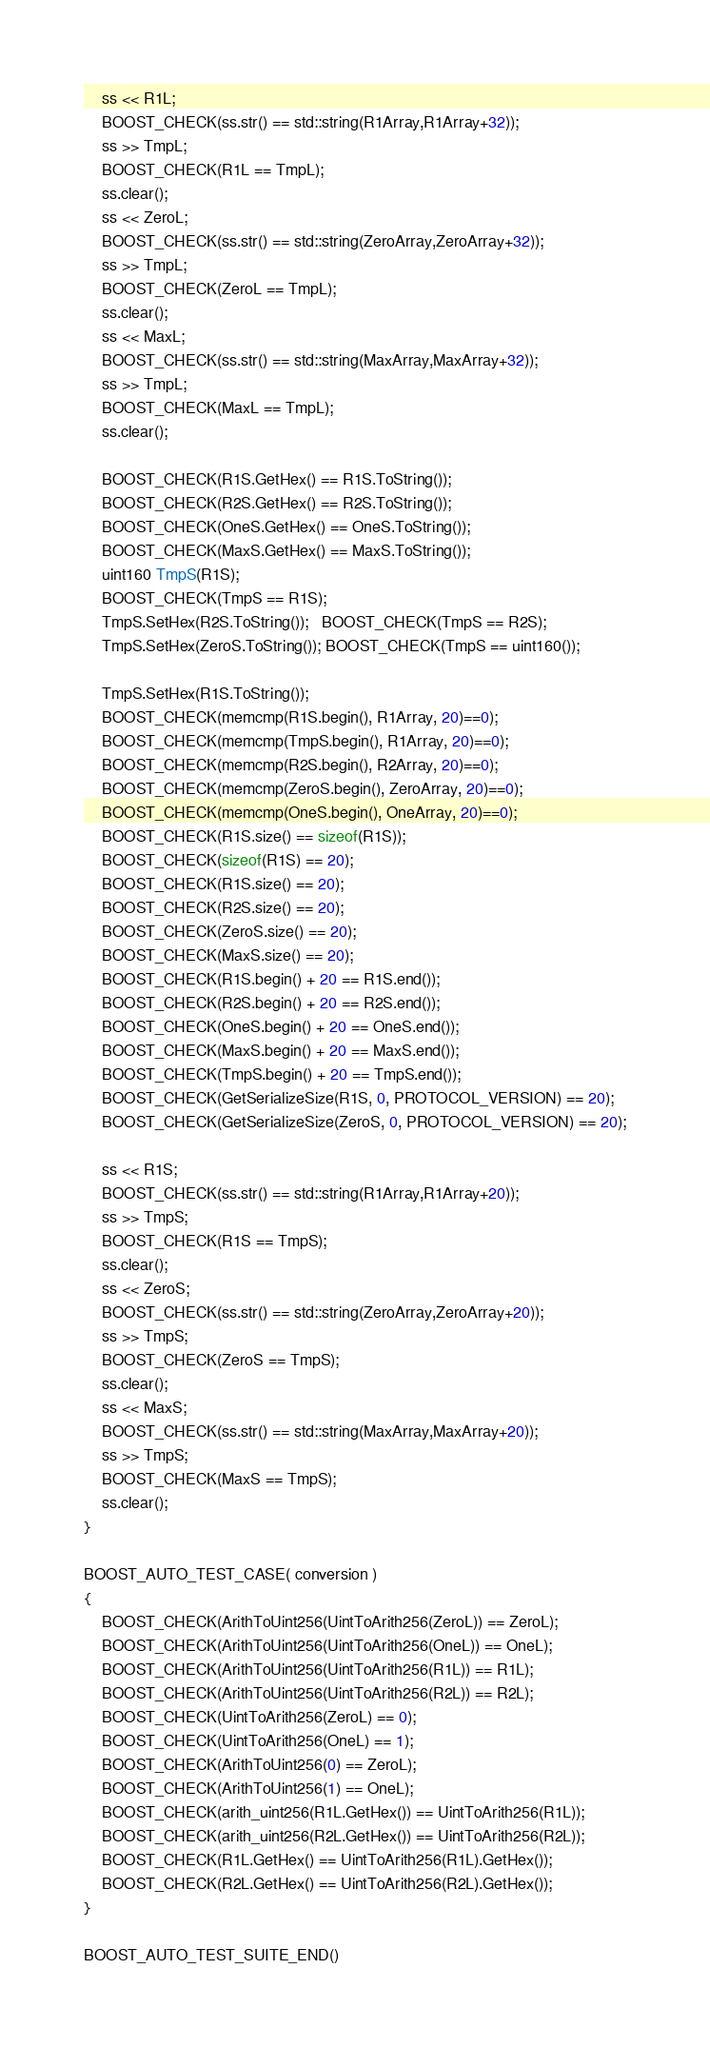Convert code to text. <code><loc_0><loc_0><loc_500><loc_500><_C++_>    ss << R1L;
    BOOST_CHECK(ss.str() == std::string(R1Array,R1Array+32));
    ss >> TmpL;
    BOOST_CHECK(R1L == TmpL);
    ss.clear();
    ss << ZeroL;
    BOOST_CHECK(ss.str() == std::string(ZeroArray,ZeroArray+32));
    ss >> TmpL;
    BOOST_CHECK(ZeroL == TmpL);
    ss.clear();
    ss << MaxL;
    BOOST_CHECK(ss.str() == std::string(MaxArray,MaxArray+32));
    ss >> TmpL;
    BOOST_CHECK(MaxL == TmpL);
    ss.clear();

    BOOST_CHECK(R1S.GetHex() == R1S.ToString());
    BOOST_CHECK(R2S.GetHex() == R2S.ToString());
    BOOST_CHECK(OneS.GetHex() == OneS.ToString());
    BOOST_CHECK(MaxS.GetHex() == MaxS.ToString());
    uint160 TmpS(R1S);
    BOOST_CHECK(TmpS == R1S);
    TmpS.SetHex(R2S.ToString());   BOOST_CHECK(TmpS == R2S);
    TmpS.SetHex(ZeroS.ToString()); BOOST_CHECK(TmpS == uint160());

    TmpS.SetHex(R1S.ToString());
    BOOST_CHECK(memcmp(R1S.begin(), R1Array, 20)==0);
    BOOST_CHECK(memcmp(TmpS.begin(), R1Array, 20)==0);
    BOOST_CHECK(memcmp(R2S.begin(), R2Array, 20)==0);
    BOOST_CHECK(memcmp(ZeroS.begin(), ZeroArray, 20)==0);
    BOOST_CHECK(memcmp(OneS.begin(), OneArray, 20)==0);
    BOOST_CHECK(R1S.size() == sizeof(R1S));
    BOOST_CHECK(sizeof(R1S) == 20);
    BOOST_CHECK(R1S.size() == 20);
    BOOST_CHECK(R2S.size() == 20);
    BOOST_CHECK(ZeroS.size() == 20);
    BOOST_CHECK(MaxS.size() == 20);
    BOOST_CHECK(R1S.begin() + 20 == R1S.end());
    BOOST_CHECK(R2S.begin() + 20 == R2S.end());
    BOOST_CHECK(OneS.begin() + 20 == OneS.end());
    BOOST_CHECK(MaxS.begin() + 20 == MaxS.end());
    BOOST_CHECK(TmpS.begin() + 20 == TmpS.end());
    BOOST_CHECK(GetSerializeSize(R1S, 0, PROTOCOL_VERSION) == 20);
    BOOST_CHECK(GetSerializeSize(ZeroS, 0, PROTOCOL_VERSION) == 20);

    ss << R1S;
    BOOST_CHECK(ss.str() == std::string(R1Array,R1Array+20));
    ss >> TmpS;
    BOOST_CHECK(R1S == TmpS);
    ss.clear();
    ss << ZeroS;
    BOOST_CHECK(ss.str() == std::string(ZeroArray,ZeroArray+20));
    ss >> TmpS;
    BOOST_CHECK(ZeroS == TmpS);
    ss.clear();
    ss << MaxS;
    BOOST_CHECK(ss.str() == std::string(MaxArray,MaxArray+20));
    ss >> TmpS;
    BOOST_CHECK(MaxS == TmpS);
    ss.clear();
}

BOOST_AUTO_TEST_CASE( conversion )
{
    BOOST_CHECK(ArithToUint256(UintToArith256(ZeroL)) == ZeroL);
    BOOST_CHECK(ArithToUint256(UintToArith256(OneL)) == OneL);
    BOOST_CHECK(ArithToUint256(UintToArith256(R1L)) == R1L);
    BOOST_CHECK(ArithToUint256(UintToArith256(R2L)) == R2L);
    BOOST_CHECK(UintToArith256(ZeroL) == 0);
    BOOST_CHECK(UintToArith256(OneL) == 1);
    BOOST_CHECK(ArithToUint256(0) == ZeroL);
    BOOST_CHECK(ArithToUint256(1) == OneL);
    BOOST_CHECK(arith_uint256(R1L.GetHex()) == UintToArith256(R1L));
    BOOST_CHECK(arith_uint256(R2L.GetHex()) == UintToArith256(R2L));
    BOOST_CHECK(R1L.GetHex() == UintToArith256(R1L).GetHex());
    BOOST_CHECK(R2L.GetHex() == UintToArith256(R2L).GetHex());
}

BOOST_AUTO_TEST_SUITE_END()
</code> 